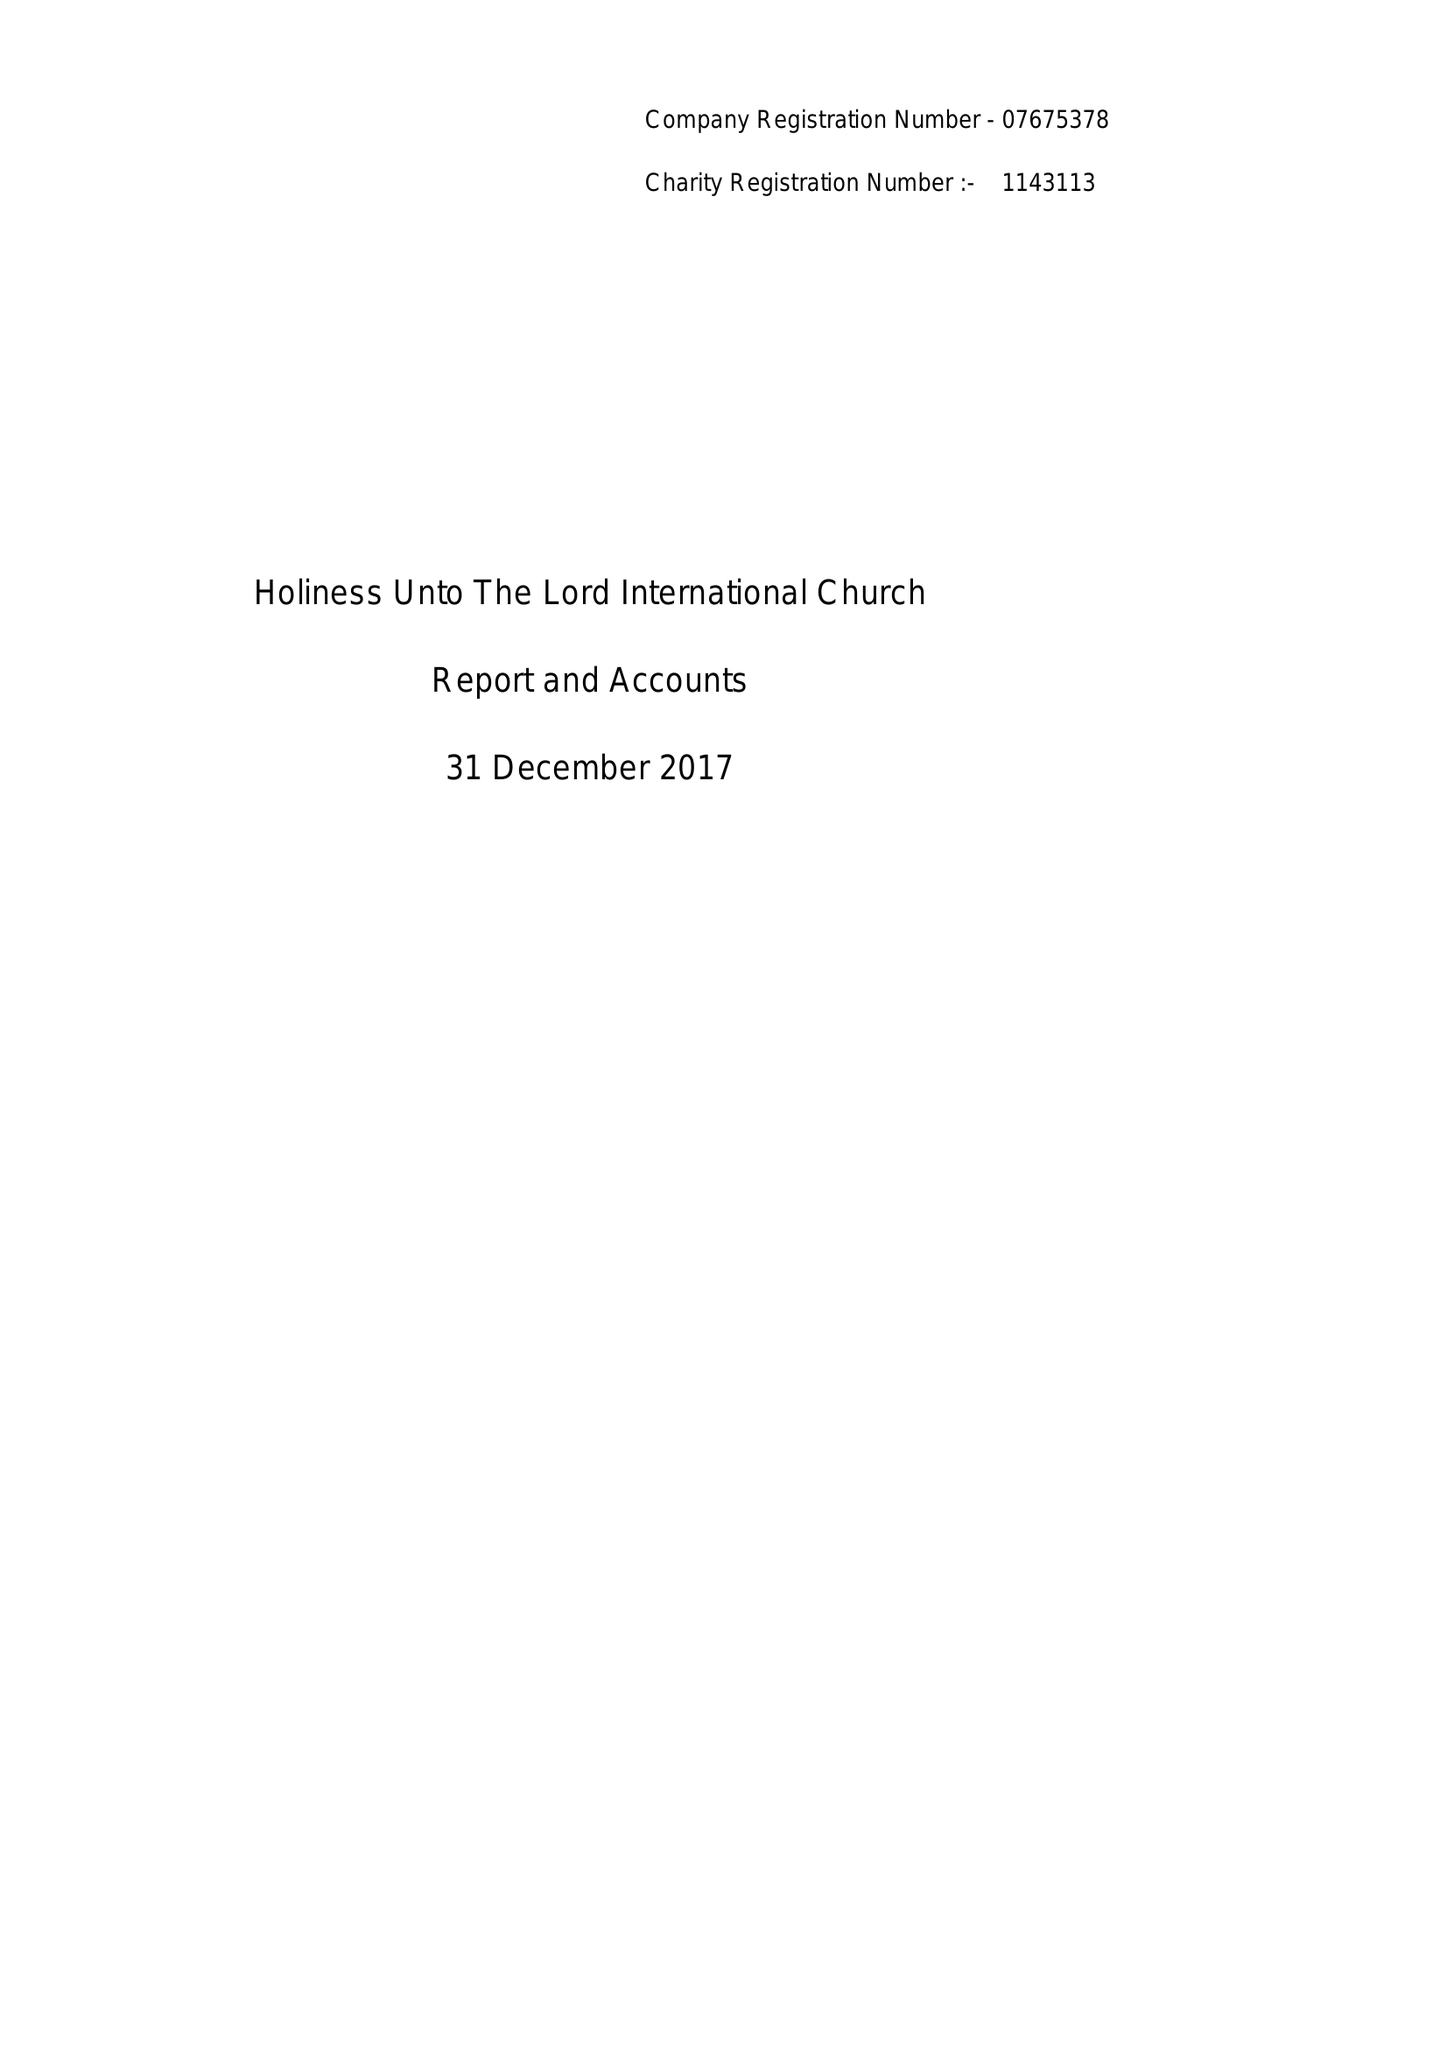What is the value for the spending_annually_in_british_pounds?
Answer the question using a single word or phrase. 78957.00 